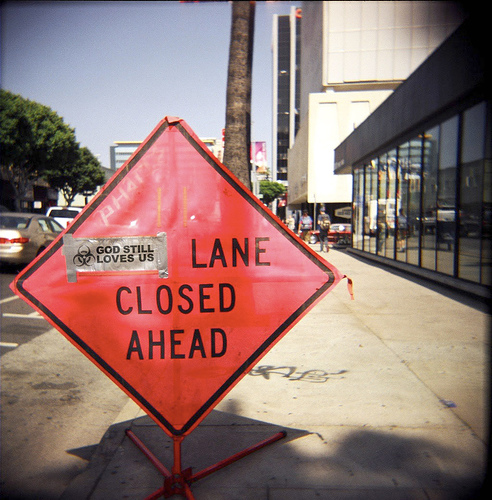Read all the text in this image. LOVES LANE CLOSED AHEAD GOD STILL PHAT US 